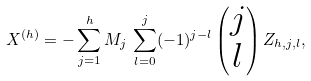Convert formula to latex. <formula><loc_0><loc_0><loc_500><loc_500>X ^ { ( h ) } = - \sum _ { j = 1 } ^ { h } M _ { j } \, \sum _ { l = 0 } ^ { j } ( - 1 ) ^ { j - l } \left ( \begin{matrix} j \\ l \end{matrix} \right ) Z _ { h , j , l } ,</formula> 